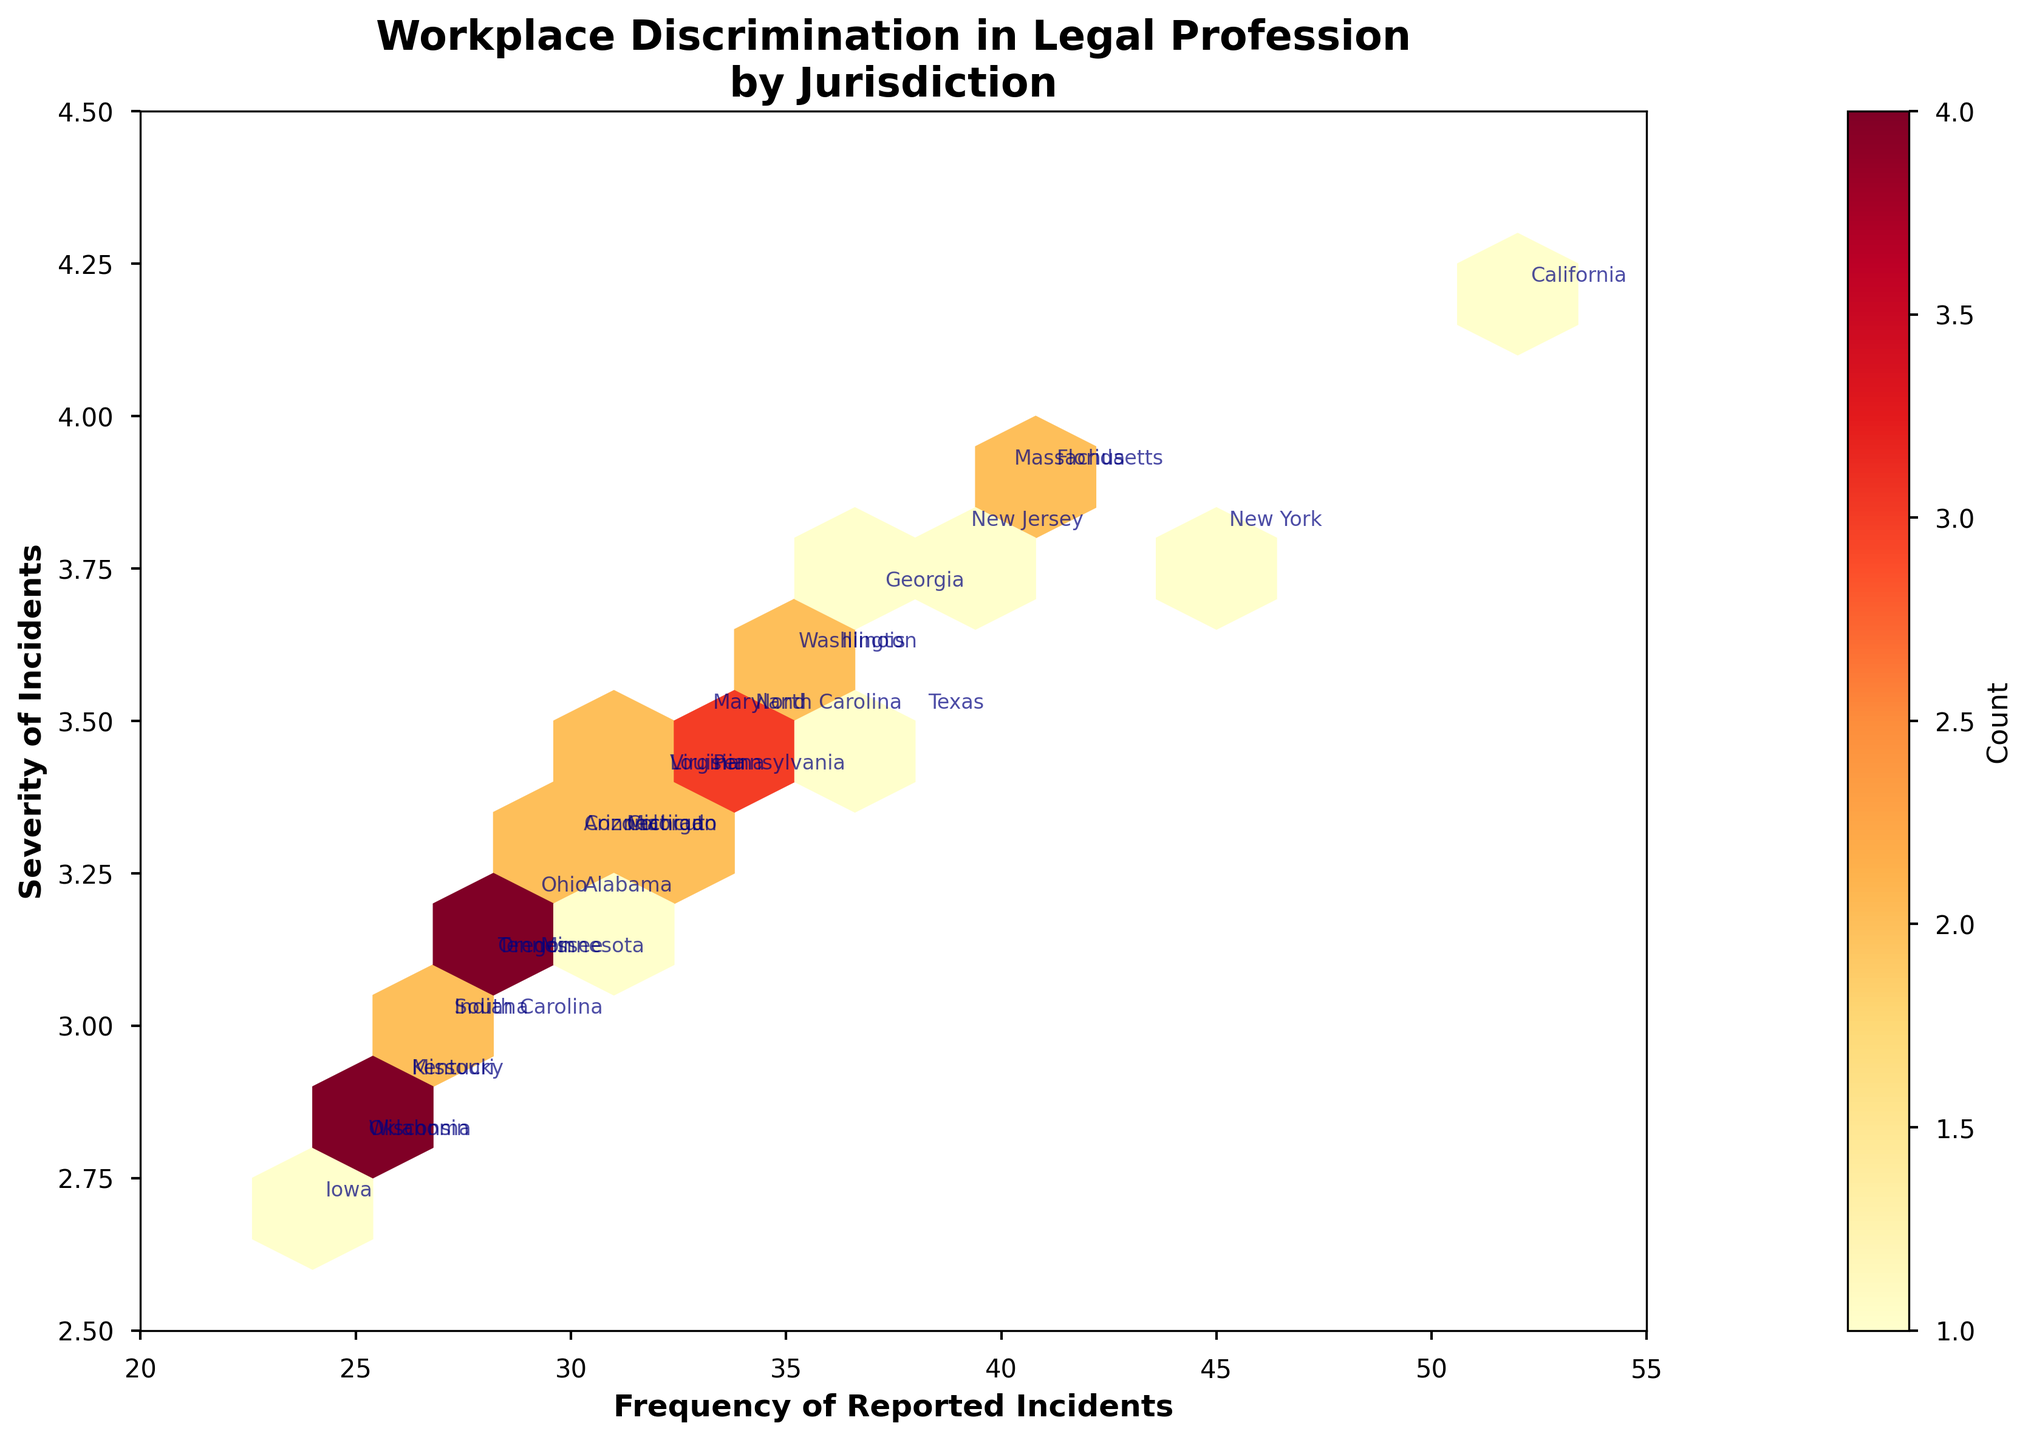How many jurisdictions are represented in the plot? Count the number of data points plotted; each data point represents a different jurisdiction. There are 30 different data points visible.
Answer: 30 What is the axis range for the Frequency of Reported Incidents? The x-axis, labeled 'Frequency of Reported Incidents', shows values ranging from 20 to 55.
Answer: 20-55 Which jurisdiction has the highest severity of incidents? Locate the data point with the highest value on the y-axis (Severity) and check the corresponding annotation. California is annotated near the highest severity value of 4.2.
Answer: California What is the average severity of reported incidents for the jurisdictions plotted? Sum the severity values for all jurisdictions and divide by the number of jurisdictions (3.8+4.2+3.5+...+2.7 = 105.9. Divide by 30).
Answer: 3.53 Which two jurisdictions have the closest reported frequencies of incidents? Find two data points on the plot whose x-values (Frequency) are closest to each other. New Jersey and Florida both have very similar frequencies around 39-41.
Answer: New Jersey and Florida Where is the highest density of data points located in terms of reported frequency and severity? Look for the area in the hexbin plot where the color is darkest, indicating the highest count of data points. The plot is densest in the area around Frequency = 30 and Severity = 3.3-3.5.
Answer: Frequency 30, Severity 3.3-3.5 How does Florida's frequency and severity compare to Texas's? Find the data points for Florida and Texas and compare their x and y coordinates. Florida has a frequency of 41 and a severity of 3.9, while Texas has a frequency of 38 and severity of 3.5.
Answer: Florida is higher in both frequency and severity What range of severity values is most frequently reported? Observe the hexbin plot and see which horizontal segments have the most count (darkest) hexes. The severity range from 3.3 to 3.6 has the most frequent reports.
Answer: 3.3 to 3.6 Which two jurisdictions have the furthest difference in severity? Identify the two data points with the most differing values on the y-axis. California has the highest severity (4.2) and Wisconsin has one of the lowest (2.8).
Answer: California and Wisconsin How do states in the 25 to 30 frequency range fare in terms of severity? Identify data points with frequencies between 25 and 30 and observe their severity values. Most states in this range have severity values around 2.8 to 3.3.
Answer: 2.8 to 3.3 